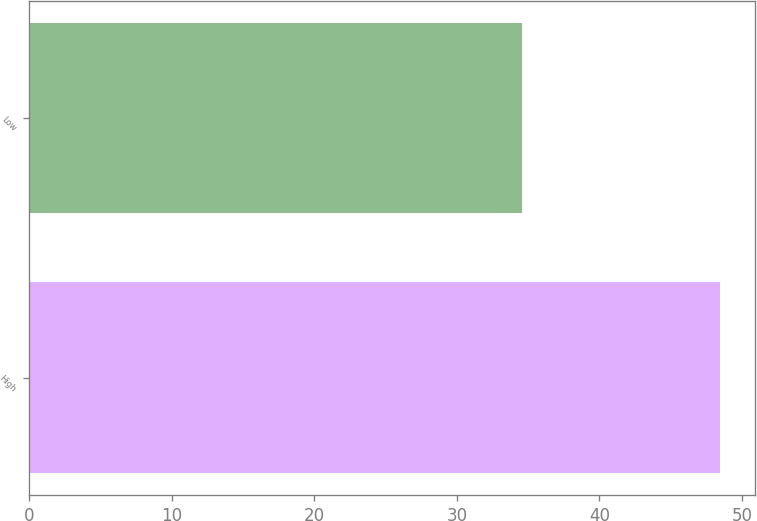<chart> <loc_0><loc_0><loc_500><loc_500><bar_chart><fcel>High<fcel>Low<nl><fcel>48.46<fcel>34.6<nl></chart> 